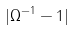Convert formula to latex. <formula><loc_0><loc_0><loc_500><loc_500>| \Omega ^ { - 1 } - 1 |</formula> 